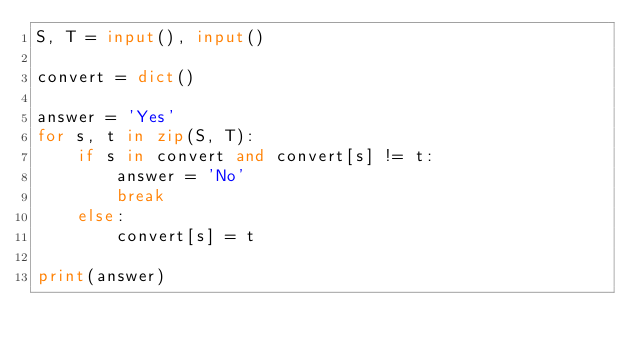Convert code to text. <code><loc_0><loc_0><loc_500><loc_500><_Python_>S, T = input(), input()

convert = dict()

answer = 'Yes'
for s, t in zip(S, T):
    if s in convert and convert[s] != t:
        answer = 'No'
        break
    else:
        convert[s] = t

print(answer)</code> 